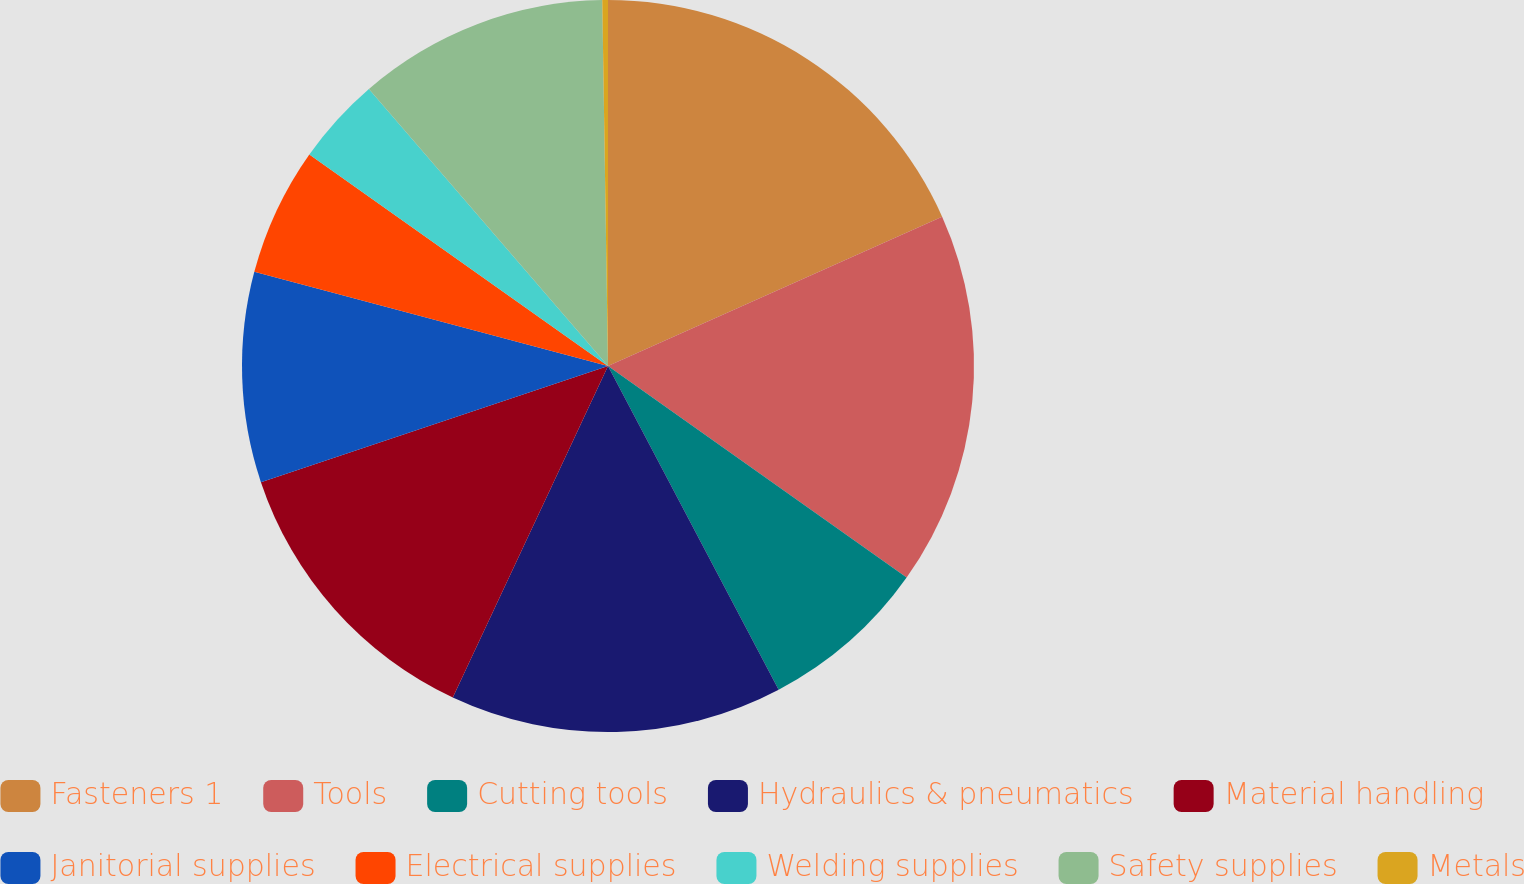Convert chart. <chart><loc_0><loc_0><loc_500><loc_500><pie_chart><fcel>Fasteners 1<fcel>Tools<fcel>Cutting tools<fcel>Hydraulics & pneumatics<fcel>Material handling<fcel>Janitorial supplies<fcel>Electrical supplies<fcel>Welding supplies<fcel>Safety supplies<fcel>Metals<nl><fcel>18.31%<fcel>16.5%<fcel>7.47%<fcel>14.69%<fcel>12.89%<fcel>9.28%<fcel>5.67%<fcel>3.86%<fcel>11.08%<fcel>0.25%<nl></chart> 